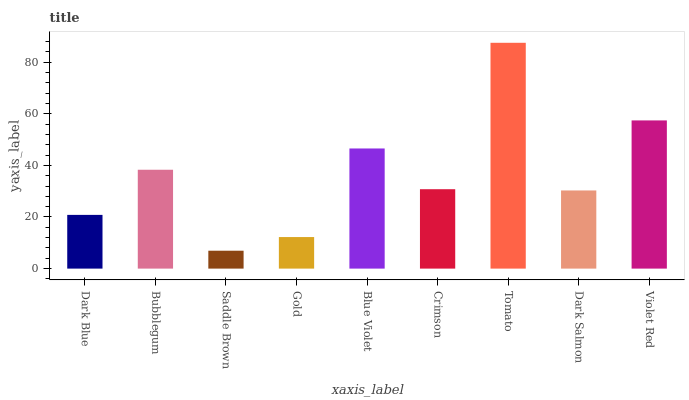Is Saddle Brown the minimum?
Answer yes or no. Yes. Is Tomato the maximum?
Answer yes or no. Yes. Is Bubblegum the minimum?
Answer yes or no. No. Is Bubblegum the maximum?
Answer yes or no. No. Is Bubblegum greater than Dark Blue?
Answer yes or no. Yes. Is Dark Blue less than Bubblegum?
Answer yes or no. Yes. Is Dark Blue greater than Bubblegum?
Answer yes or no. No. Is Bubblegum less than Dark Blue?
Answer yes or no. No. Is Crimson the high median?
Answer yes or no. Yes. Is Crimson the low median?
Answer yes or no. Yes. Is Dark Blue the high median?
Answer yes or no. No. Is Dark Blue the low median?
Answer yes or no. No. 